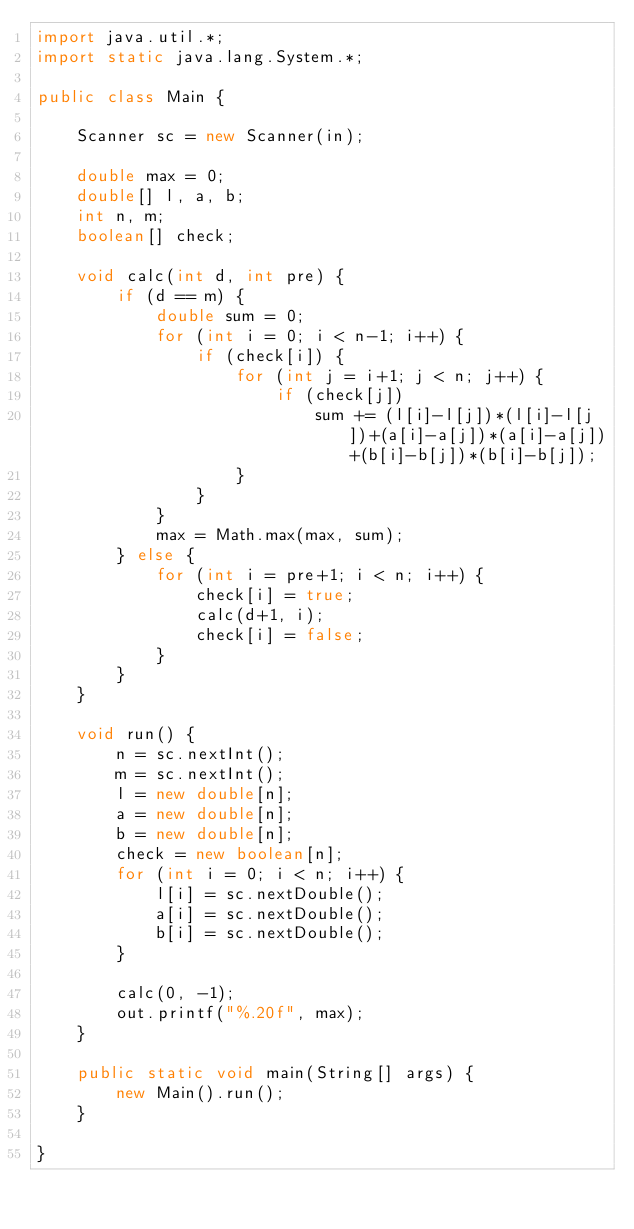Convert code to text. <code><loc_0><loc_0><loc_500><loc_500><_Java_>import java.util.*;
import static java.lang.System.*;

public class Main {

	Scanner sc = new Scanner(in);
	
	double max = 0;
	double[] l, a, b;
	int n, m;
	boolean[] check;
	
	void calc(int d, int pre) {
		if (d == m) {
			double sum = 0;
			for (int i = 0; i < n-1; i++) {
				if (check[i]) {
					for (int j = i+1; j < n; j++) {
						if (check[j])
							sum += (l[i]-l[j])*(l[i]-l[j])+(a[i]-a[j])*(a[i]-a[j])+(b[i]-b[j])*(b[i]-b[j]);
					}
				}
			}
			max = Math.max(max, sum);
		} else {
			for (int i = pre+1; i < n; i++) {
				check[i] = true;
				calc(d+1, i);
				check[i] = false;
			}
		}
	}
	
	void run() {
		n = sc.nextInt();
		m = sc.nextInt();
		l = new double[n];
		a = new double[n];
		b = new double[n];
		check = new boolean[n];
		for (int i = 0; i < n; i++) {
			l[i] = sc.nextDouble();
			a[i] = sc.nextDouble();
			b[i] = sc.nextDouble();
		}
		
		calc(0, -1);
		out.printf("%.20f", max);
	}
	
	public static void main(String[] args) {
		new Main().run();
	}

}</code> 